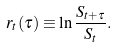<formula> <loc_0><loc_0><loc_500><loc_500>r _ { t } ( \tau ) \equiv \ln \frac { S _ { t + \tau } } { S _ { t } } .</formula> 